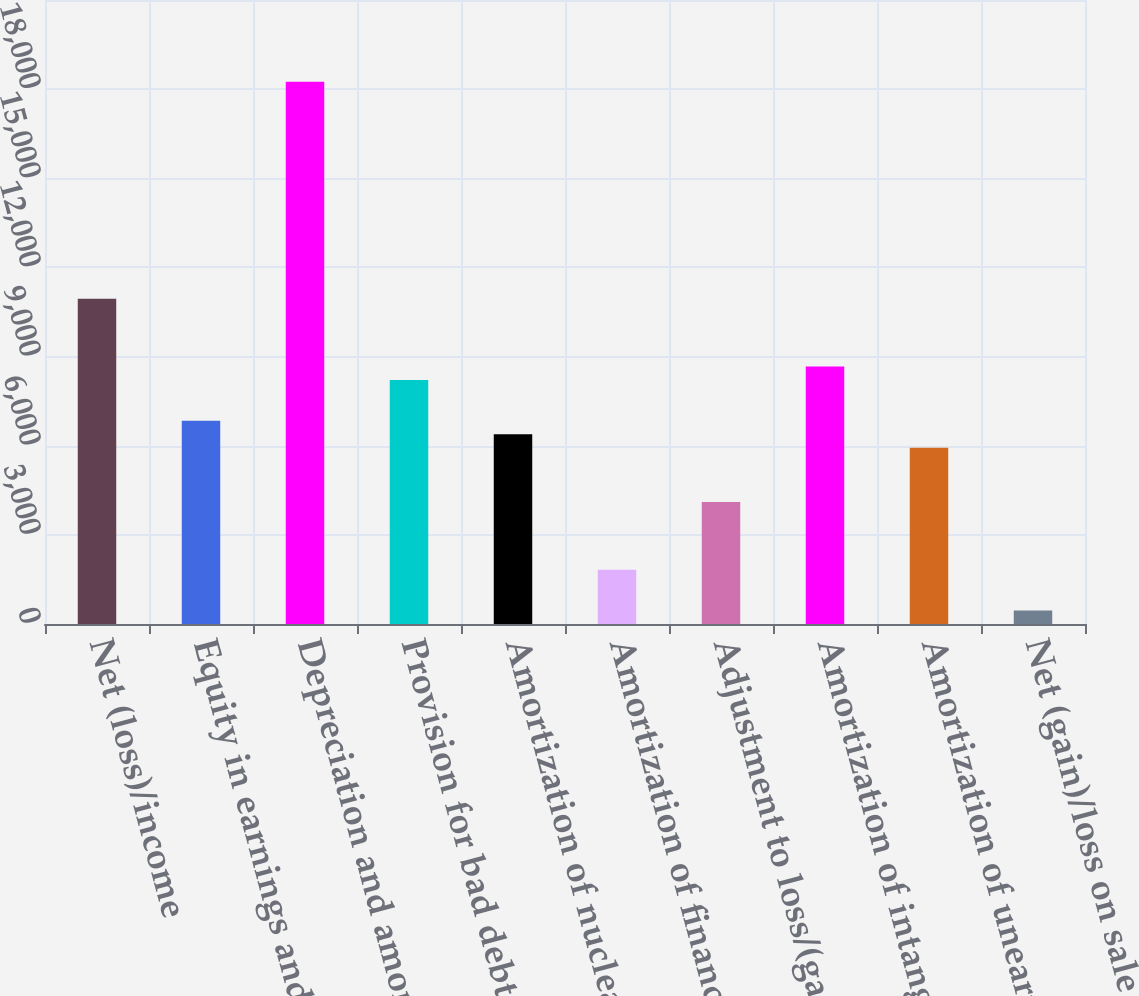Convert chart. <chart><loc_0><loc_0><loc_500><loc_500><bar_chart><fcel>Net (loss)/income<fcel>Equity in earnings and<fcel>Depreciation and amortization<fcel>Provision for bad debts<fcel>Amortization of nuclear fuel<fcel>Amortization of financing<fcel>Adjustment to loss/(gain) on<fcel>Amortization of intangibles<fcel>Amortization of unearned<fcel>Net (gain)/loss on sale of<nl><fcel>10948.4<fcel>6843.5<fcel>18246<fcel>8211.8<fcel>6387.4<fcel>1826.4<fcel>4106.9<fcel>8667.9<fcel>5931.3<fcel>458.1<nl></chart> 